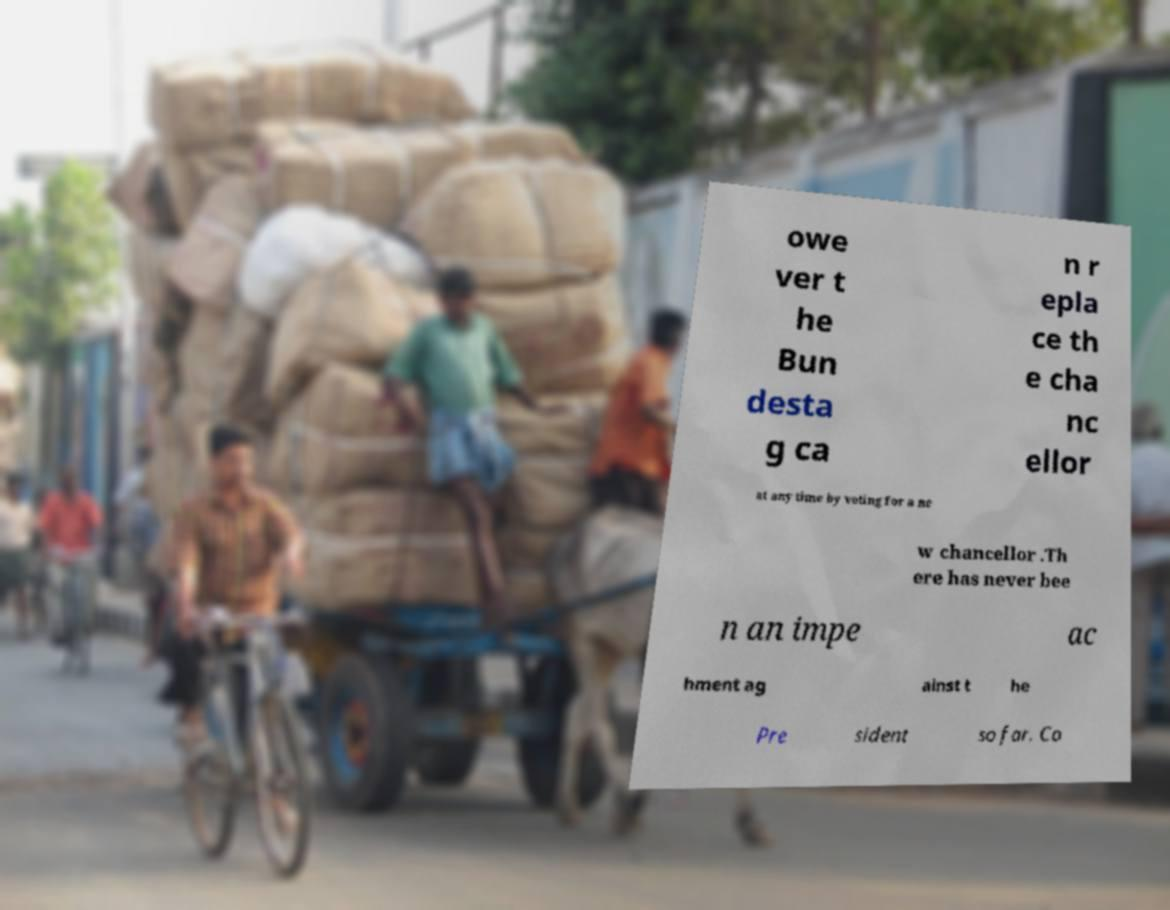Could you extract and type out the text from this image? owe ver t he Bun desta g ca n r epla ce th e cha nc ellor at any time by voting for a ne w chancellor .Th ere has never bee n an impe ac hment ag ainst t he Pre sident so far. Co 